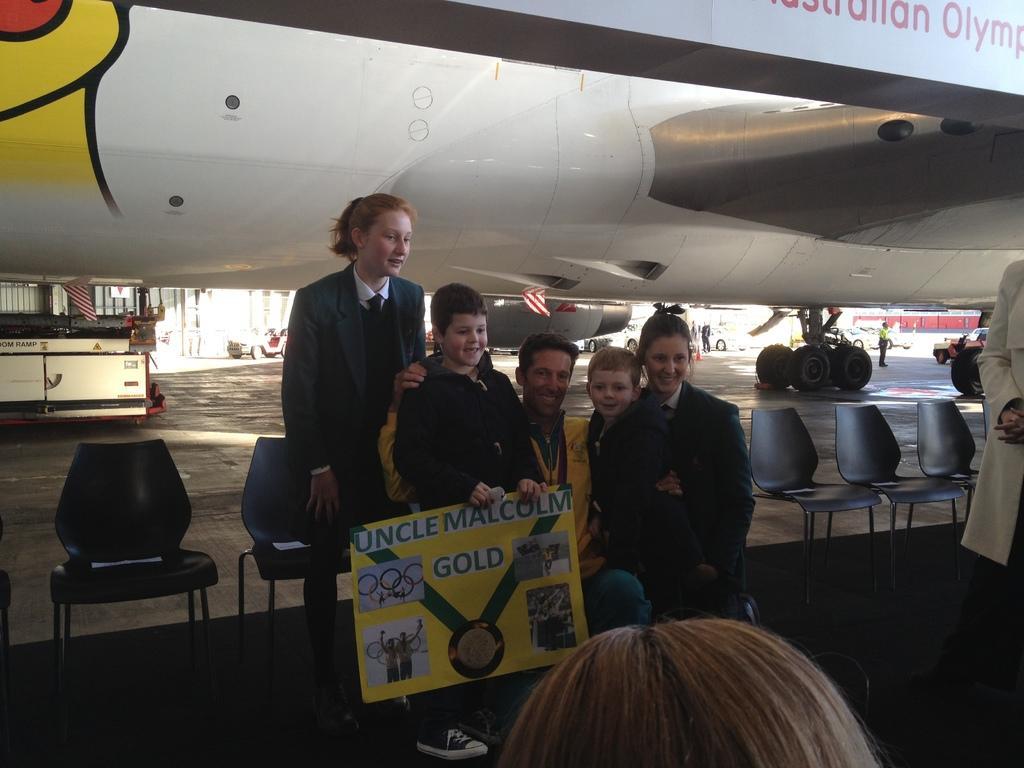Please provide a concise description of this image. In this picture we can see man in front smiling and holding children's with their hand and here woman standing above them and here we have some chairs and in background we can see airplane, flag and on right person standing here head of a person. 